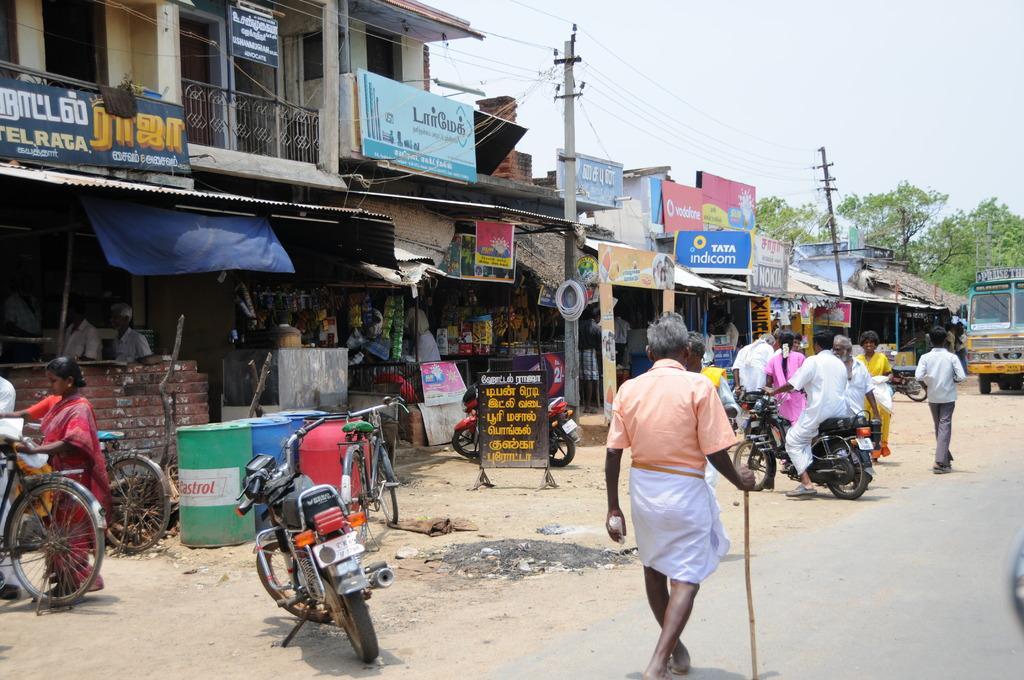How would you summarize this image in a sentence or two? There are groups of ships and there are group of people in front of the shops. 